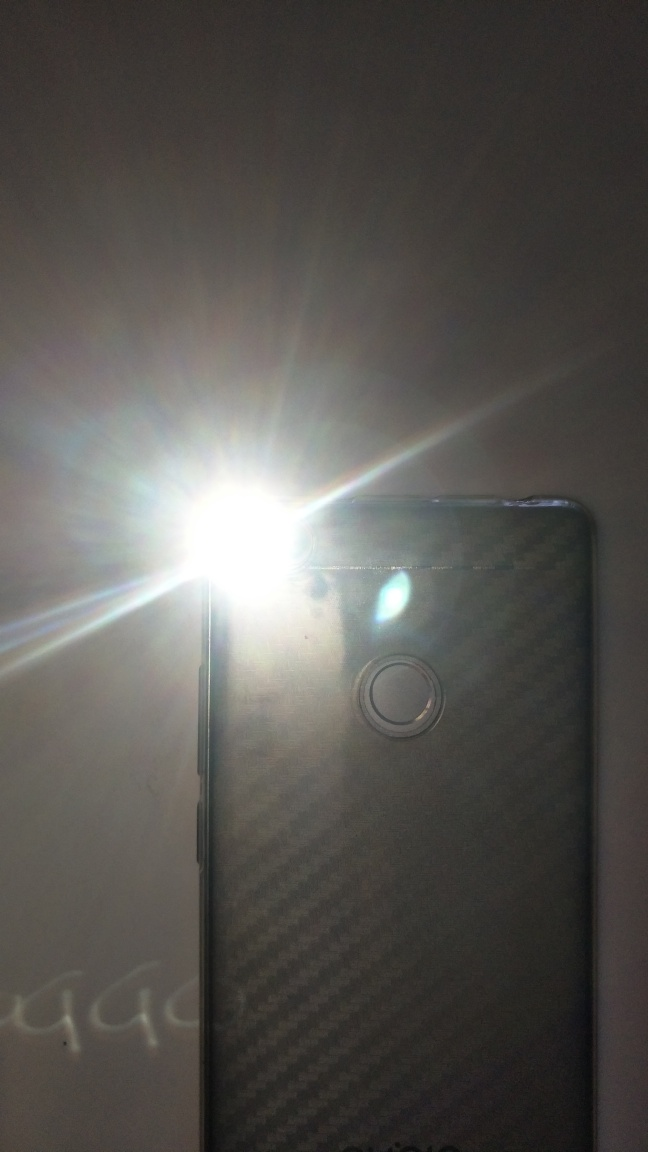Is there anything unique about the camera setup on the phone? From the visible evidence, there appears to be a single camera lens shown, which is relatively unique in an era where many smartphones have multiple lenses to support wide-angle or zoomed-in shots. This could indicate a focus on simplicity or a model that precedes the multi-lens trend. 